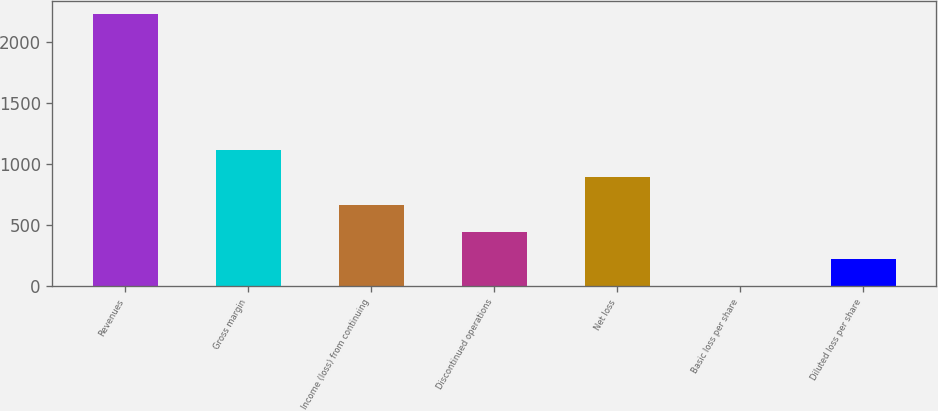<chart> <loc_0><loc_0><loc_500><loc_500><bar_chart><fcel>Revenues<fcel>Gross margin<fcel>Income (loss) from continuing<fcel>Discontinued operations<fcel>Net loss<fcel>Basic loss per share<fcel>Diluted loss per share<nl><fcel>2228<fcel>1114.28<fcel>668.8<fcel>446.06<fcel>891.54<fcel>0.58<fcel>223.32<nl></chart> 